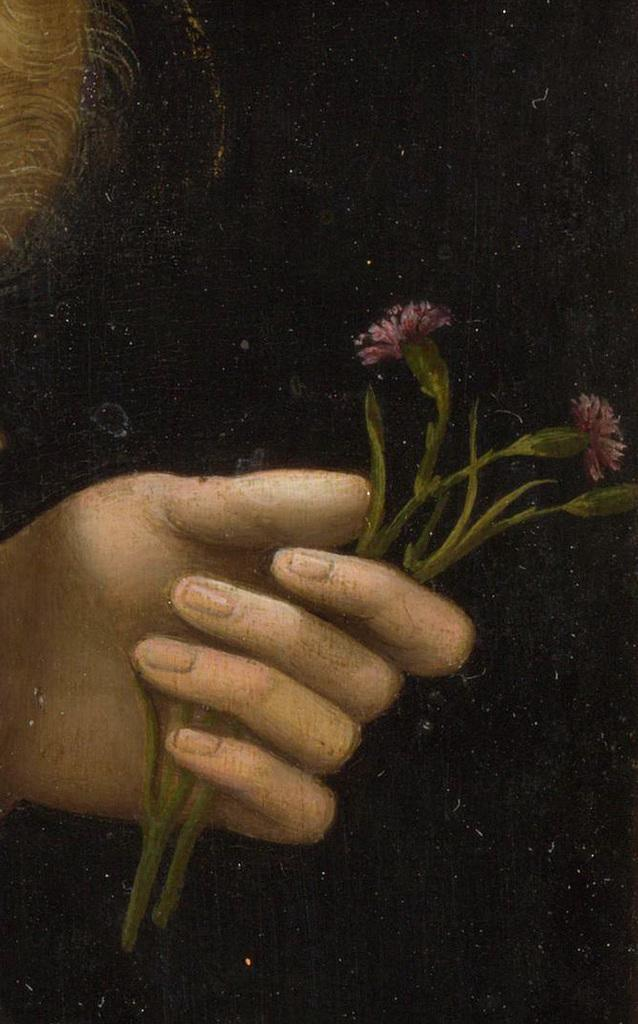What can be observed about the image in terms of editing? The image is edited. What is the main subject of the image? There is a person's hand in the image. What is the hand holding? The hand is holding flowers. Where are the hand and flowers located in the image? The hand and flowers are in the center of the image. What type of calendar is hanging on the wall behind the hand in the image? There is no wall or calendar visible in the image; it only features a person's hand holding flowers in the center. What color is the marble table on which the hand is resting in the image? There is no table, marble or otherwise, present in the image; it only features a person's hand holding flowers in the center. 